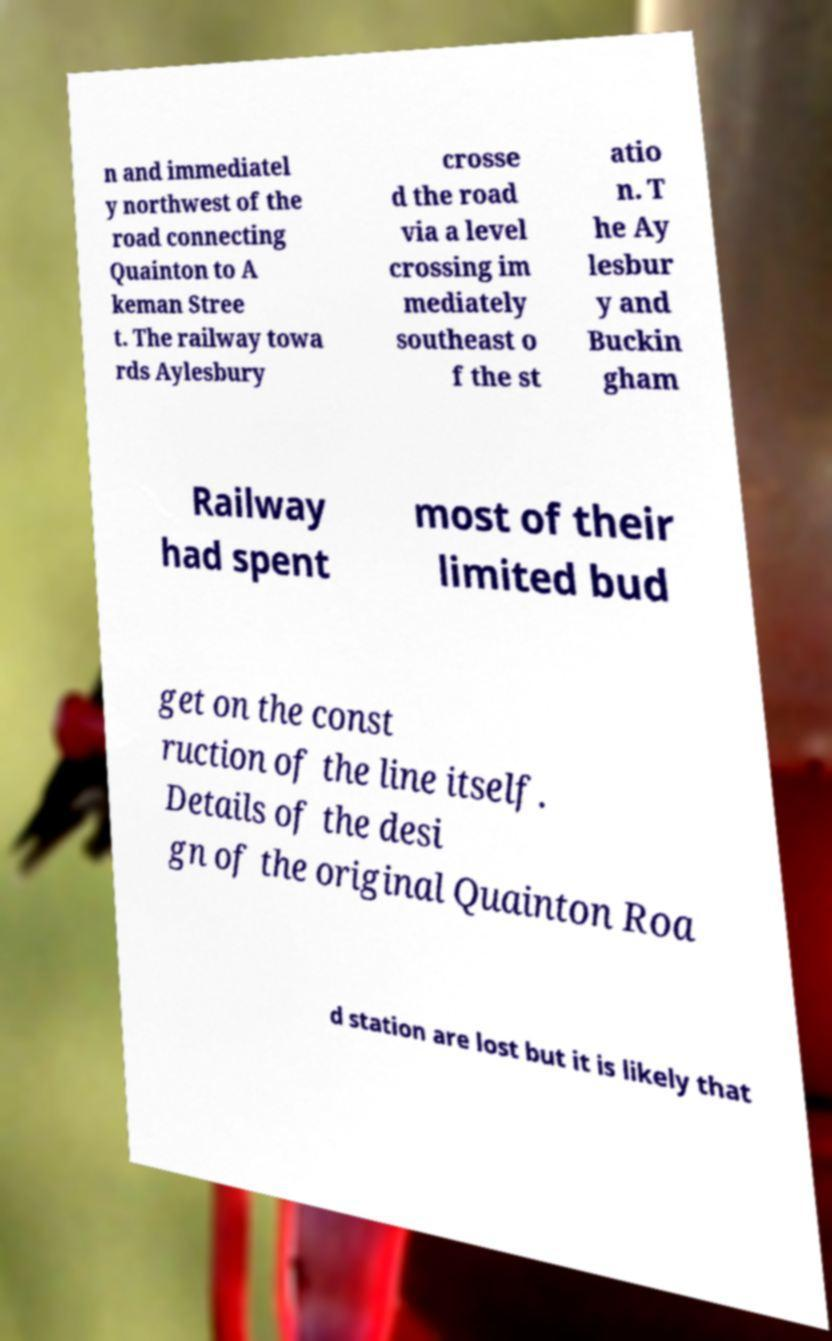There's text embedded in this image that I need extracted. Can you transcribe it verbatim? n and immediatel y northwest of the road connecting Quainton to A keman Stree t. The railway towa rds Aylesbury crosse d the road via a level crossing im mediately southeast o f the st atio n. T he Ay lesbur y and Buckin gham Railway had spent most of their limited bud get on the const ruction of the line itself. Details of the desi gn of the original Quainton Roa d station are lost but it is likely that 